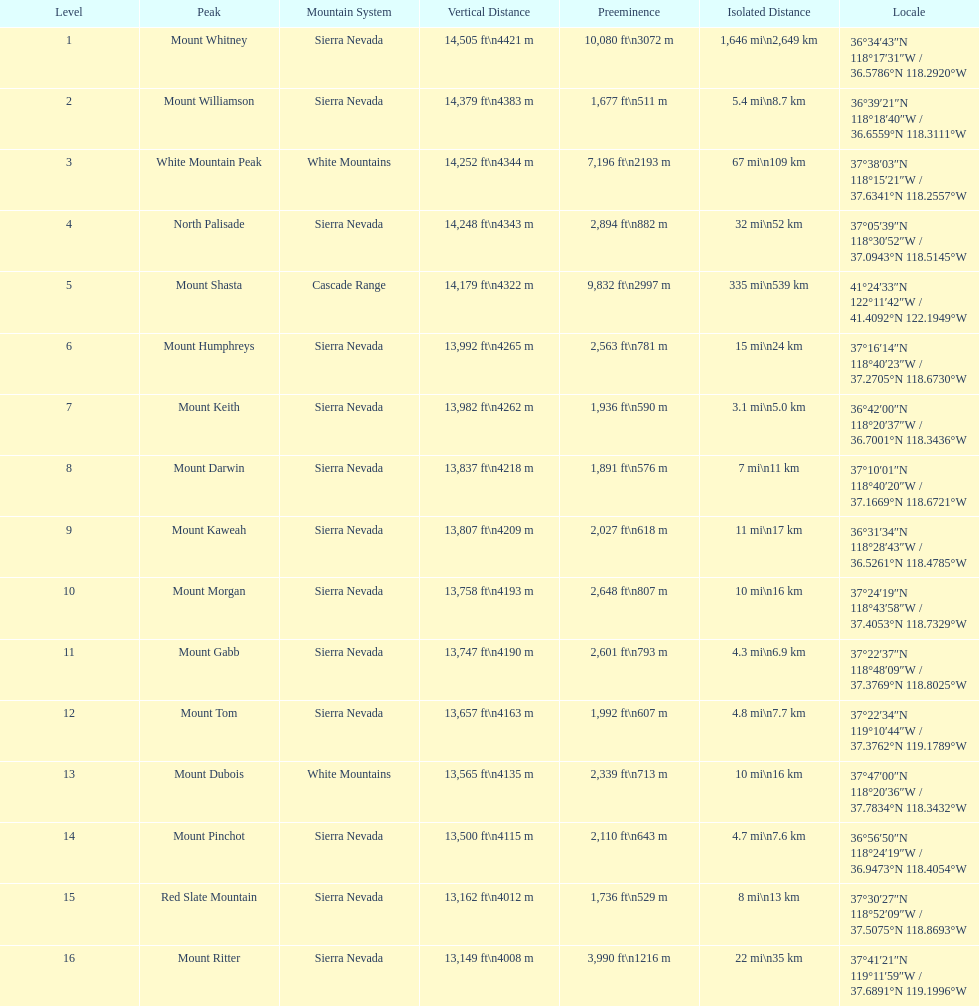What is the tallest peak in the sierra nevadas? Mount Whitney. 